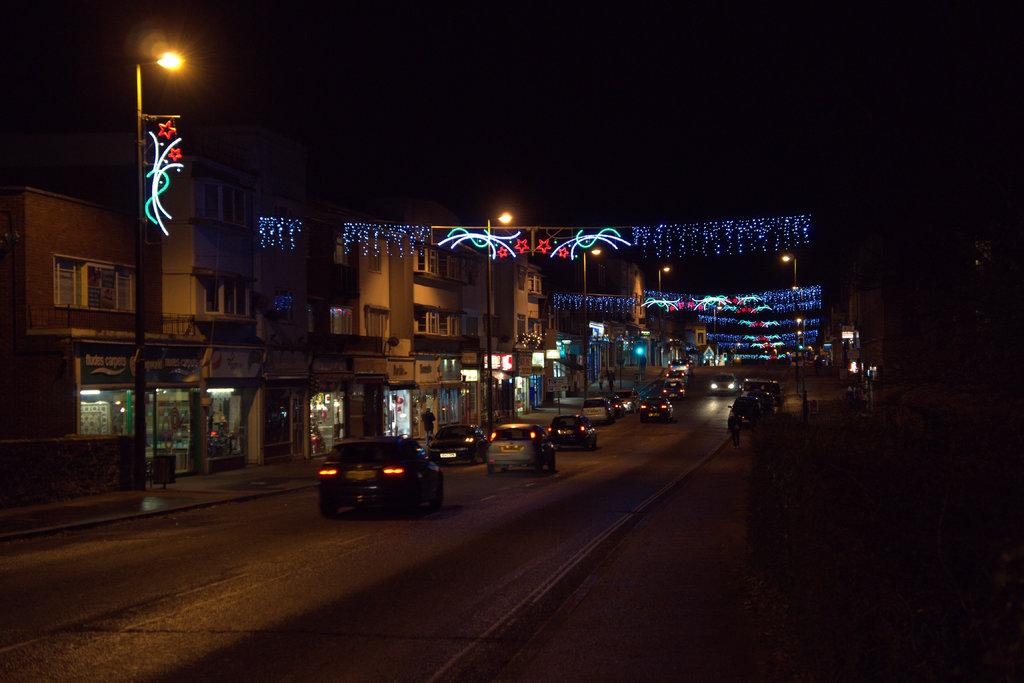What type of structures are visible in the image? There is a group of buildings in the image. What can be found inside the buildings? There are stores in the buildings. What else can be seen in the image besides the buildings? There are vehicles in the image. What are the street poles used for in the image? There are street poles in the middle of the image, and they have lights on them. Can you see a gun being used by someone in the image? No, there is no gun visible in the image. What type of twig can be seen growing from the roof of one of the buildings? There is no twig growing from the roof of any building in the image. 